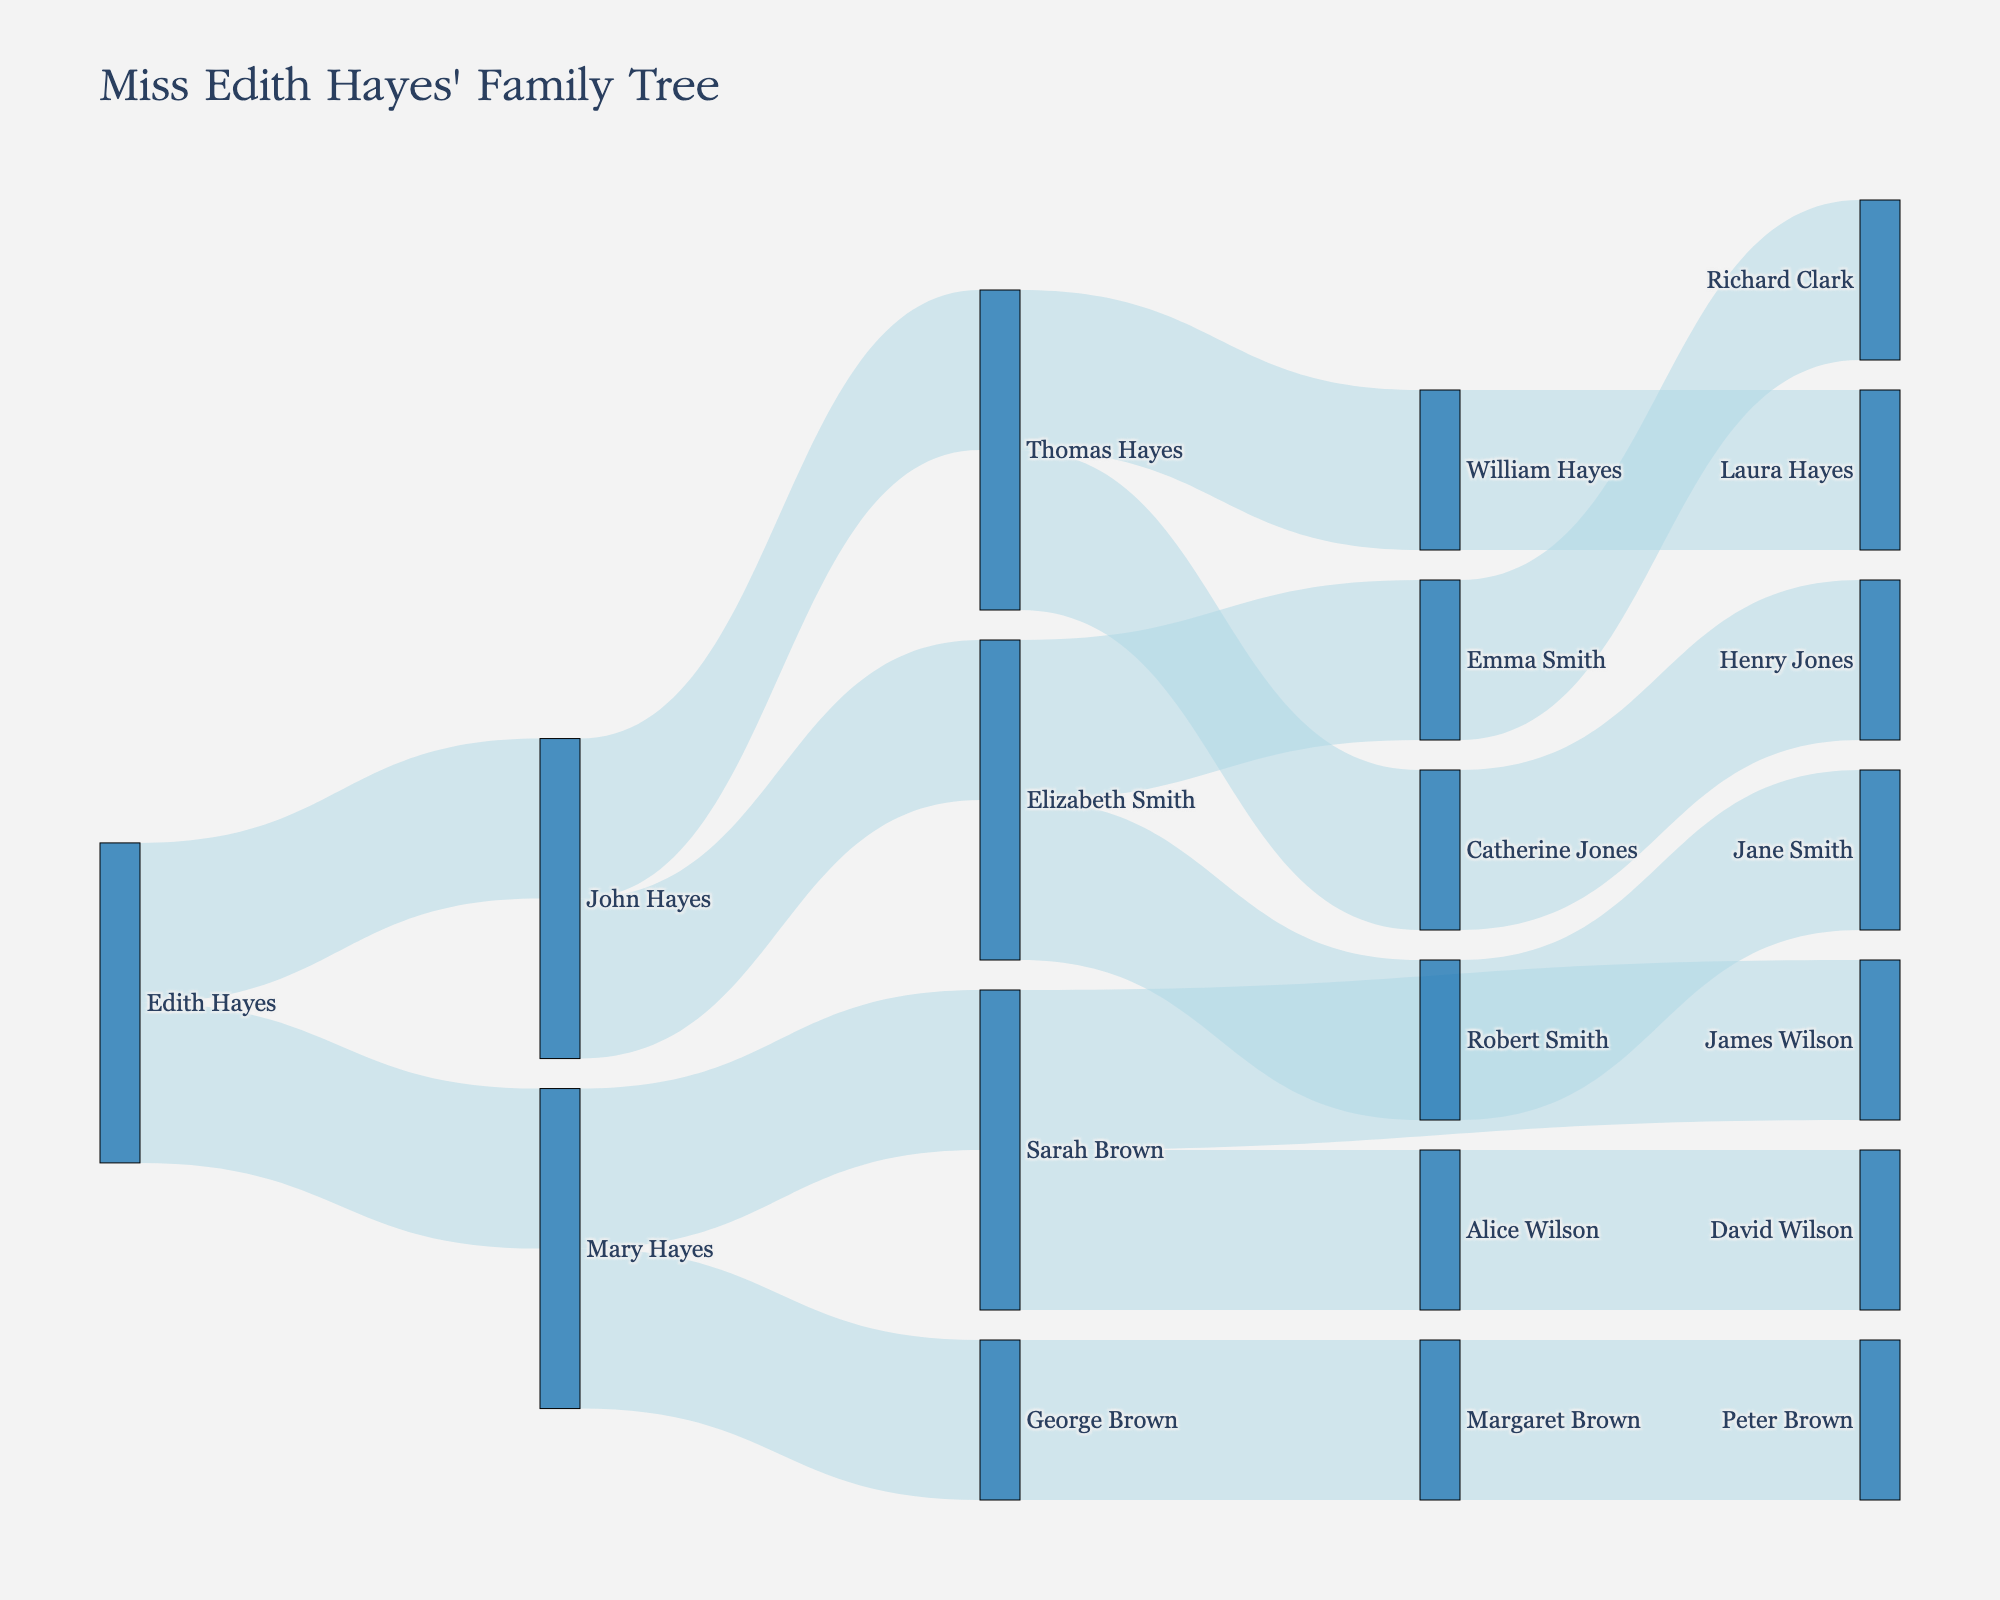Who is the title of the family tree diagram dedicated to? The title of the family tree diagram is "Miss Edith Hayes' Family Tree," so the diagram is dedicated to Miss Edith Hayes.
Answer: Miss Edith Hayes What color are the links between the nodes? The links between the nodes in the Sankey diagram are colored light blue.
Answer: Light blue How many children does John Hayes have? John Hayes has two lines, or connections, extending from him representing his children. Those connections lead to Elizabeth Smith and Thomas Hayes.
Answer: Two Who are the children of Sarah Brown? The lines extending from Sarah Brown lead to James Wilson and Alice Wilson, indicating they are her children.
Answer: James Wilson and Alice Wilson Between John Hayes and Mary Hayes, who has more children? John Hayes has two children (Elizabeth Smith and Thomas Hayes), while Mary Hayes also has two children (George Brown and Sarah Brown). Thus, they have an equal number of children.
Answer: Equal How many grandchildren does Edith Hayes have, from both of her children combined? Edith Hayes' descendants are traced through her children, John Hayes and Mary Hayes. John Hayes has two children (Elizabeth Smith and Thomas Hayes), and Mary Hayes has two children (George Brown and Sarah Brown). Adding them together gives four grandchildren.
Answer: Four Which branch of Edith Hayes' family has a greater number of overall descendants, the one from John Hayes or the one from Mary Hayes? The descendants of John Hayes are Elizabeth Smith (2 children), Thomas Hayes (2 children), so four in total. The descendants of Mary Hayes are George Brown (1 child), Sarah Brown (2 children), so three in total. Thus, John Hayes has more overall descendants.
Answer: John Hayes Who is the final descendant of Margaret Brown? The line extending from Margaret Brown leads to Peter Brown, indicating he is the final descendant mentioned in this dataset.
Answer: Peter Brown 